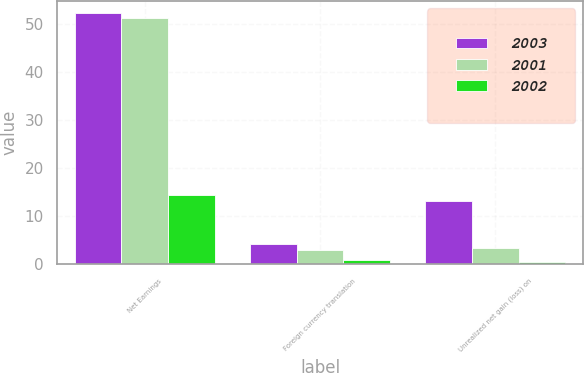Convert chart. <chart><loc_0><loc_0><loc_500><loc_500><stacked_bar_chart><ecel><fcel>Net Earnings<fcel>Foreign currency translation<fcel>Unrealized net gain (loss) on<nl><fcel>2003<fcel>52.2<fcel>4.2<fcel>13.1<nl><fcel>2001<fcel>51.3<fcel>3.1<fcel>3.4<nl><fcel>2002<fcel>14.5<fcel>1<fcel>0.4<nl></chart> 